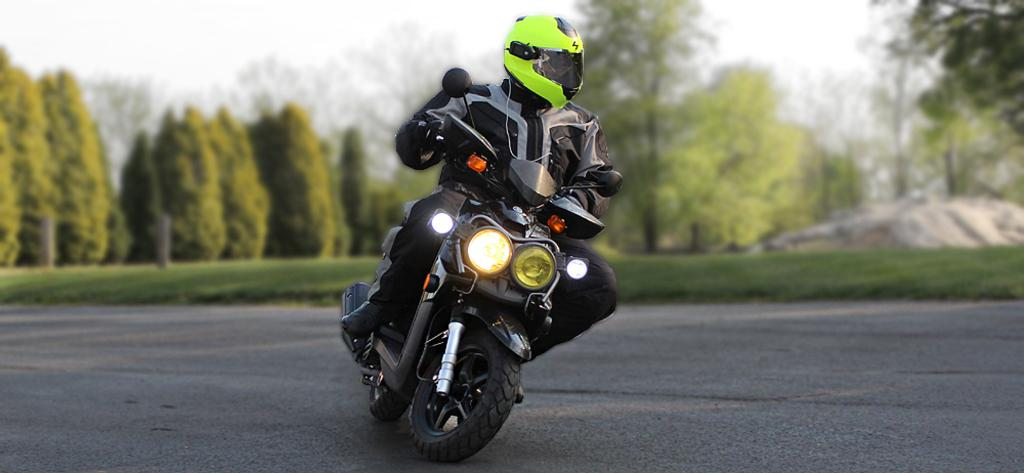What is the main subject of the image? There is a person in the image. What is the person wearing? The person is wearing a jacket and helmet. What activity is the person engaged in? The person is riding a bike. Where is the bike located? The bike is on a road. What can be seen in the background of the image? There are trees on the grassland in the background, and the sky is visible above. What type of government is depicted in the image? There is no government depicted in the image; it features a person riding a bike on a road. Can you tell me how many ships are visible in the image? There are no ships present in the image; it shows a person riding a bike on a road with trees and the sky in the background. 